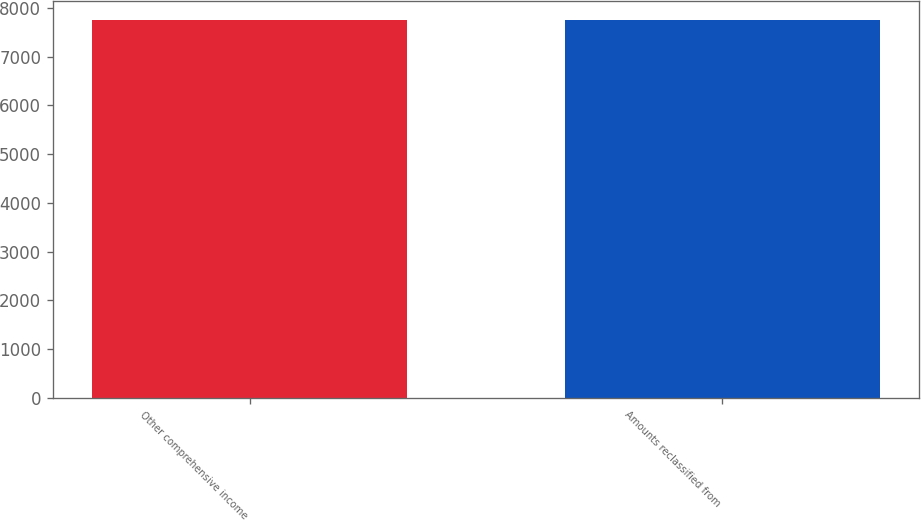<chart> <loc_0><loc_0><loc_500><loc_500><bar_chart><fcel>Other comprehensive income<fcel>Amounts reclassified from<nl><fcel>7752<fcel>7752.1<nl></chart> 